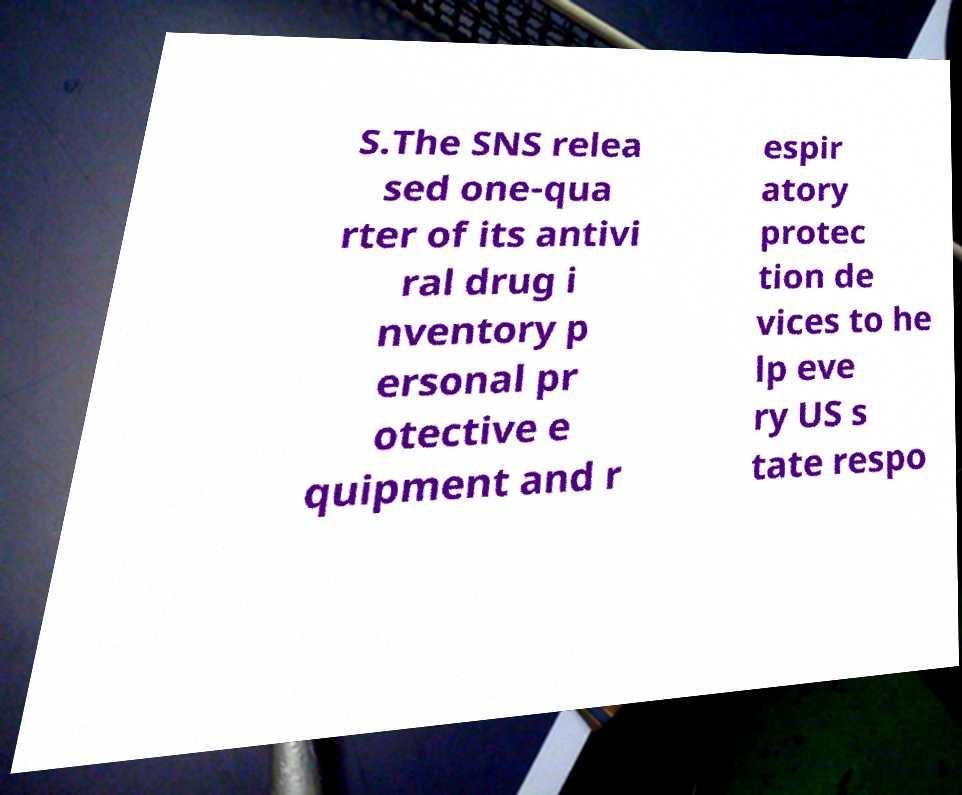There's text embedded in this image that I need extracted. Can you transcribe it verbatim? S.The SNS relea sed one-qua rter of its antivi ral drug i nventory p ersonal pr otective e quipment and r espir atory protec tion de vices to he lp eve ry US s tate respo 